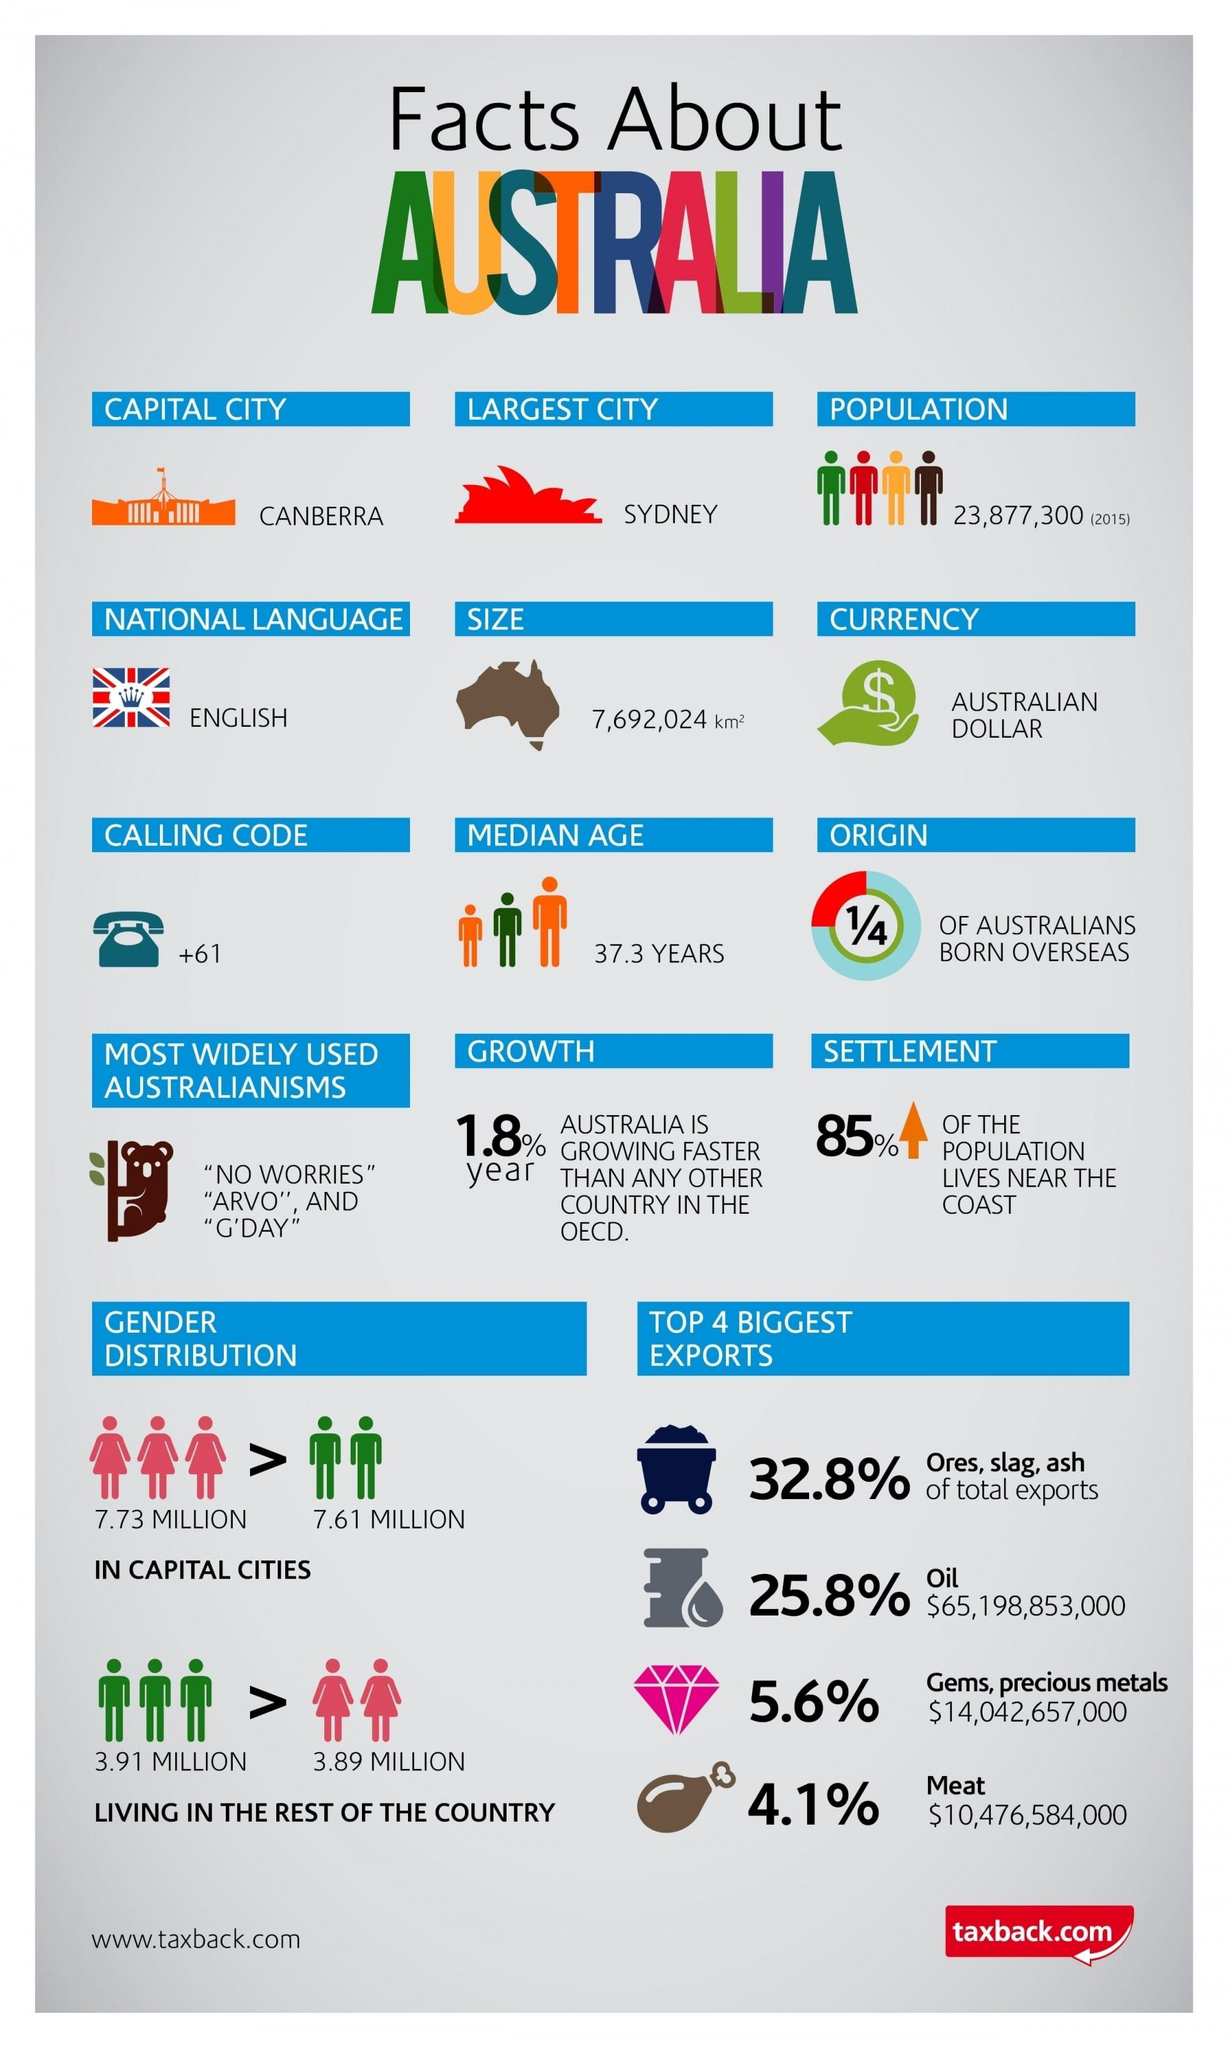Highlight a few significant elements in this photo. The population of females in capital cities is 0.12 times higher than that of males. According to the given data, the top 4 biggest exports collectively hold a market share of 68.3% in the total export market. The export market is covered by meat and gems/precious metals/precious metals, accounting for 9.7% of the total market. The population of males in the rest of the country is approximately 0.02 times higher than that of females, according to the given information. Sydney is the largest city in Australia. 